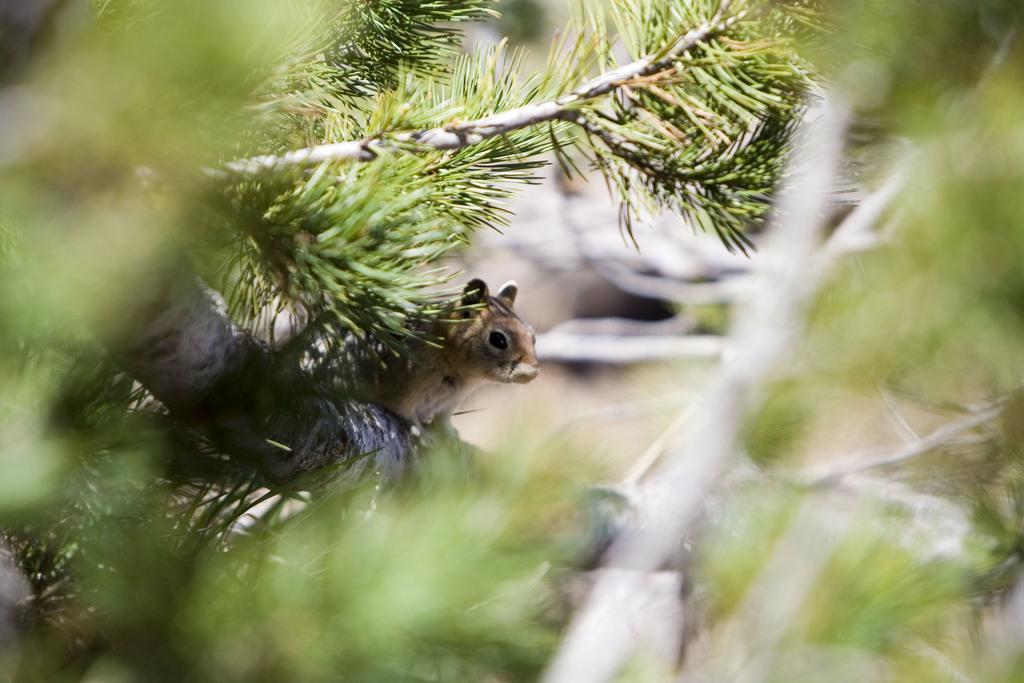Could you give a brief overview of what you see in this image? In the center of the image we can see a tree with branches and leaves. On the tree, we can see a squirrel. In the background, we can see it is blurred. 